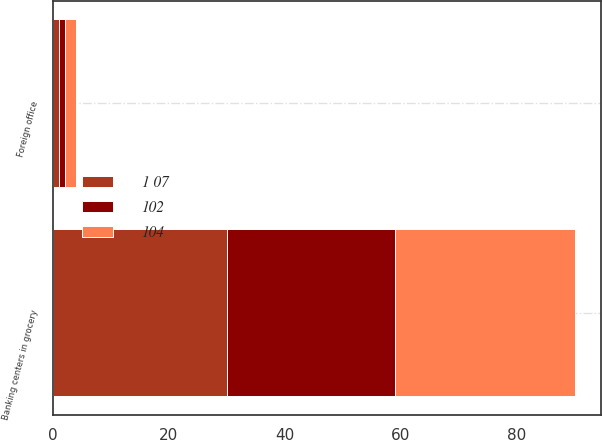Convert chart. <chart><loc_0><loc_0><loc_500><loc_500><stacked_bar_chart><ecel><fcel>Banking centers in grocery<fcel>Foreign office<nl><fcel>102<fcel>29<fcel>1<nl><fcel>1 07<fcel>30<fcel>1<nl><fcel>104<fcel>31<fcel>2<nl></chart> 